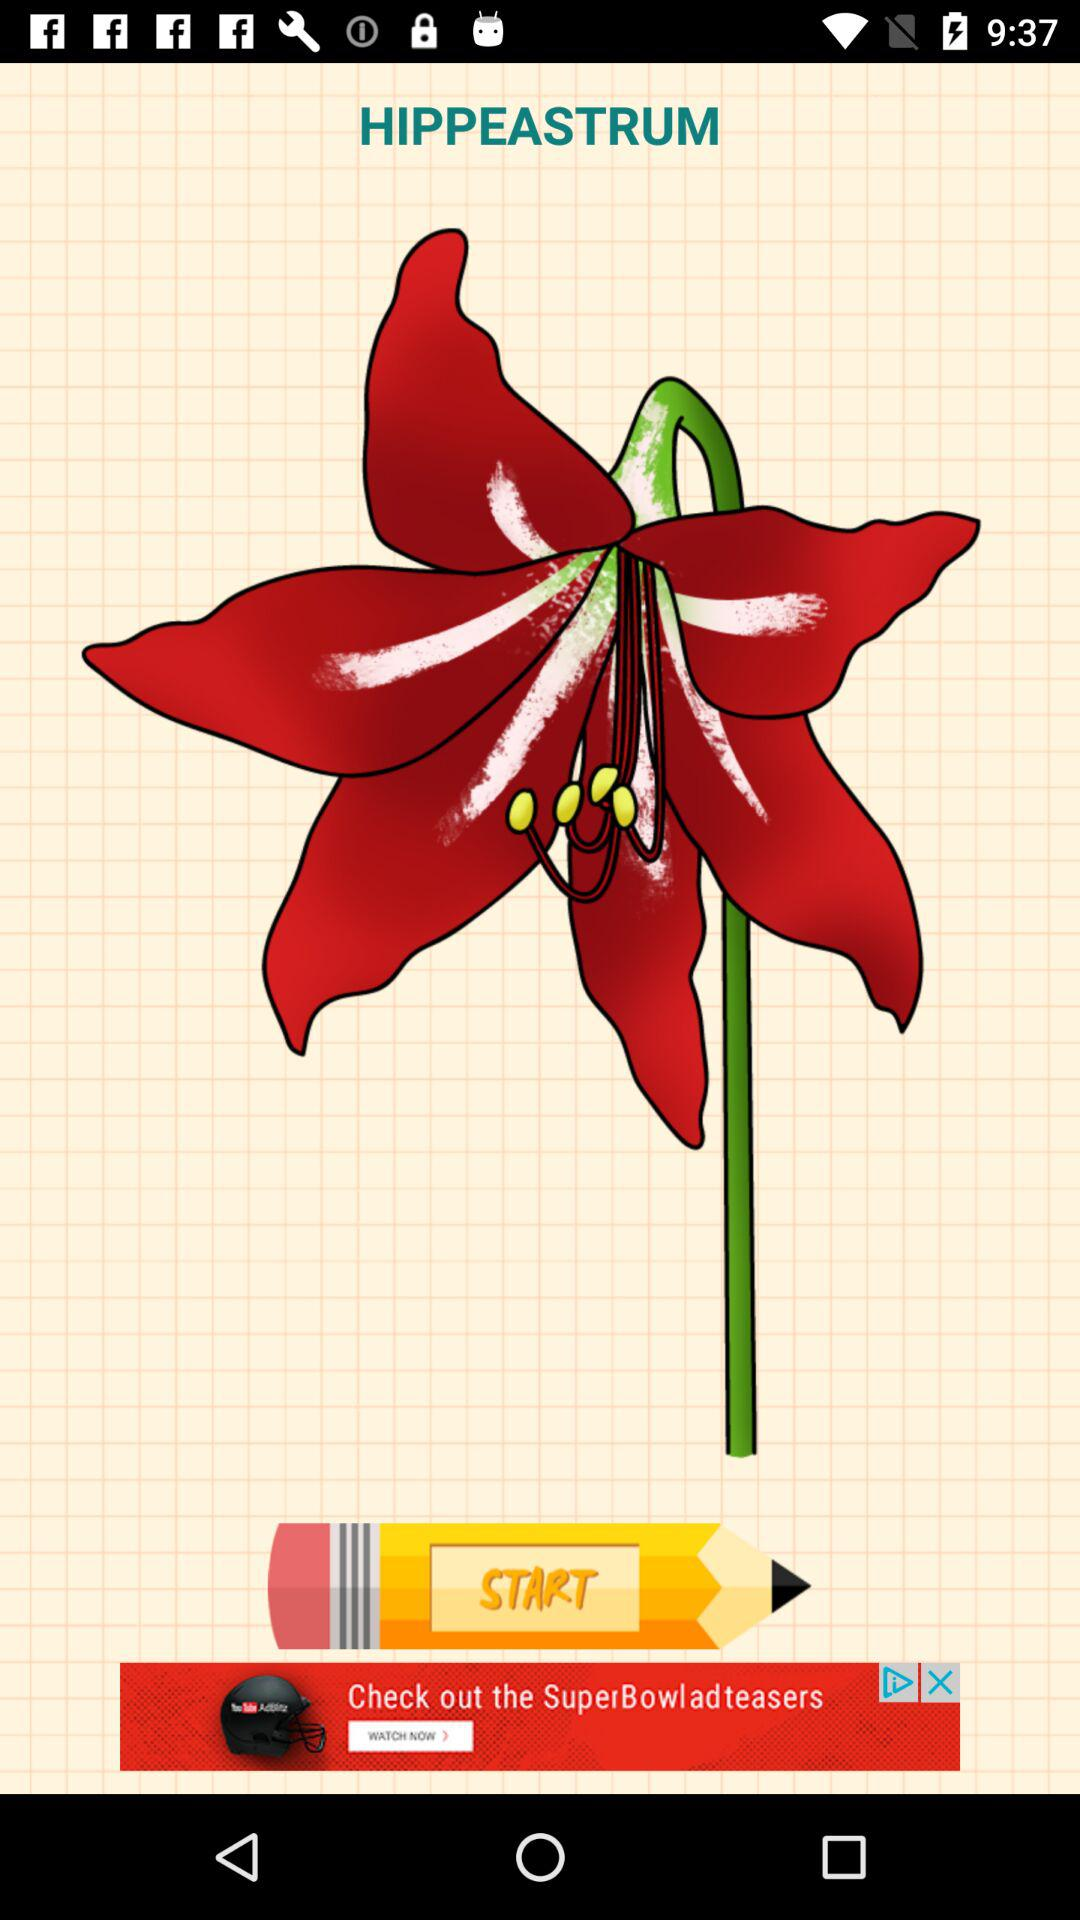What is the name of the image? The name of the image is "HIPPEASTRUM". 